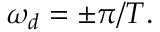<formula> <loc_0><loc_0><loc_500><loc_500>\omega _ { d } = \pm \pi / T .</formula> 